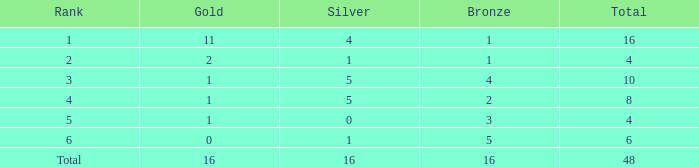What is the total gold that has bronze less than 2, a silver of 1 and total more than 4? None. 